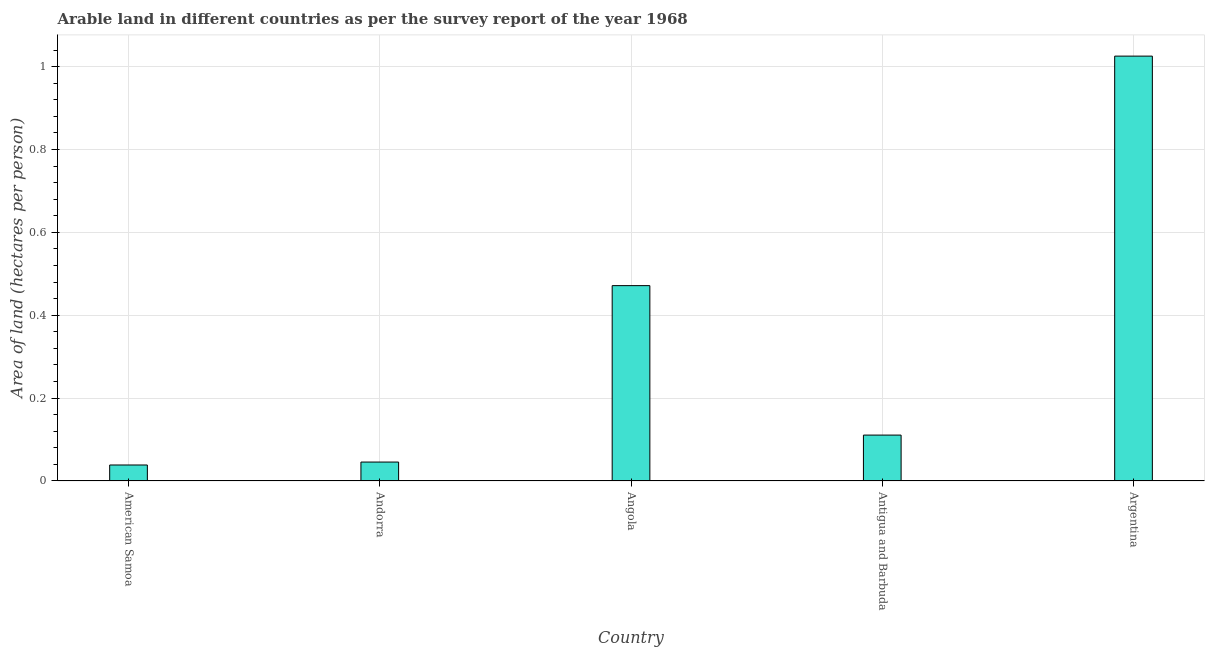Does the graph contain grids?
Offer a terse response. Yes. What is the title of the graph?
Ensure brevity in your answer.  Arable land in different countries as per the survey report of the year 1968. What is the label or title of the X-axis?
Your response must be concise. Country. What is the label or title of the Y-axis?
Your answer should be compact. Area of land (hectares per person). What is the area of arable land in Antigua and Barbuda?
Your response must be concise. 0.11. Across all countries, what is the maximum area of arable land?
Provide a short and direct response. 1.03. Across all countries, what is the minimum area of arable land?
Offer a terse response. 0.04. In which country was the area of arable land minimum?
Offer a very short reply. American Samoa. What is the sum of the area of arable land?
Provide a succinct answer. 1.69. What is the difference between the area of arable land in American Samoa and Angola?
Make the answer very short. -0.43. What is the average area of arable land per country?
Offer a very short reply. 0.34. What is the median area of arable land?
Your answer should be very brief. 0.11. In how many countries, is the area of arable land greater than 0.6 hectares per person?
Offer a very short reply. 1. What is the ratio of the area of arable land in Antigua and Barbuda to that in Argentina?
Ensure brevity in your answer.  0.11. Is the area of arable land in Antigua and Barbuda less than that in Argentina?
Ensure brevity in your answer.  Yes. What is the difference between the highest and the second highest area of arable land?
Your answer should be compact. 0.55. What is the difference between the highest and the lowest area of arable land?
Your answer should be compact. 0.99. How many bars are there?
Your answer should be very brief. 5. Are all the bars in the graph horizontal?
Keep it short and to the point. No. How many countries are there in the graph?
Offer a very short reply. 5. Are the values on the major ticks of Y-axis written in scientific E-notation?
Your answer should be very brief. No. What is the Area of land (hectares per person) of American Samoa?
Provide a short and direct response. 0.04. What is the Area of land (hectares per person) in Andorra?
Your answer should be compact. 0.05. What is the Area of land (hectares per person) of Angola?
Provide a short and direct response. 0.47. What is the Area of land (hectares per person) in Antigua and Barbuda?
Your answer should be compact. 0.11. What is the Area of land (hectares per person) of Argentina?
Your answer should be very brief. 1.03. What is the difference between the Area of land (hectares per person) in American Samoa and Andorra?
Provide a succinct answer. -0.01. What is the difference between the Area of land (hectares per person) in American Samoa and Angola?
Your answer should be compact. -0.43. What is the difference between the Area of land (hectares per person) in American Samoa and Antigua and Barbuda?
Give a very brief answer. -0.07. What is the difference between the Area of land (hectares per person) in American Samoa and Argentina?
Provide a short and direct response. -0.99. What is the difference between the Area of land (hectares per person) in Andorra and Angola?
Your answer should be very brief. -0.43. What is the difference between the Area of land (hectares per person) in Andorra and Antigua and Barbuda?
Make the answer very short. -0.07. What is the difference between the Area of land (hectares per person) in Andorra and Argentina?
Ensure brevity in your answer.  -0.98. What is the difference between the Area of land (hectares per person) in Angola and Antigua and Barbuda?
Give a very brief answer. 0.36. What is the difference between the Area of land (hectares per person) in Angola and Argentina?
Offer a terse response. -0.55. What is the difference between the Area of land (hectares per person) in Antigua and Barbuda and Argentina?
Keep it short and to the point. -0.91. What is the ratio of the Area of land (hectares per person) in American Samoa to that in Andorra?
Give a very brief answer. 0.85. What is the ratio of the Area of land (hectares per person) in American Samoa to that in Angola?
Provide a short and direct response. 0.08. What is the ratio of the Area of land (hectares per person) in American Samoa to that in Antigua and Barbuda?
Provide a short and direct response. 0.35. What is the ratio of the Area of land (hectares per person) in American Samoa to that in Argentina?
Offer a terse response. 0.04. What is the ratio of the Area of land (hectares per person) in Andorra to that in Angola?
Make the answer very short. 0.1. What is the ratio of the Area of land (hectares per person) in Andorra to that in Antigua and Barbuda?
Your answer should be very brief. 0.41. What is the ratio of the Area of land (hectares per person) in Andorra to that in Argentina?
Offer a very short reply. 0.04. What is the ratio of the Area of land (hectares per person) in Angola to that in Antigua and Barbuda?
Give a very brief answer. 4.25. What is the ratio of the Area of land (hectares per person) in Angola to that in Argentina?
Provide a short and direct response. 0.46. What is the ratio of the Area of land (hectares per person) in Antigua and Barbuda to that in Argentina?
Provide a short and direct response. 0.11. 